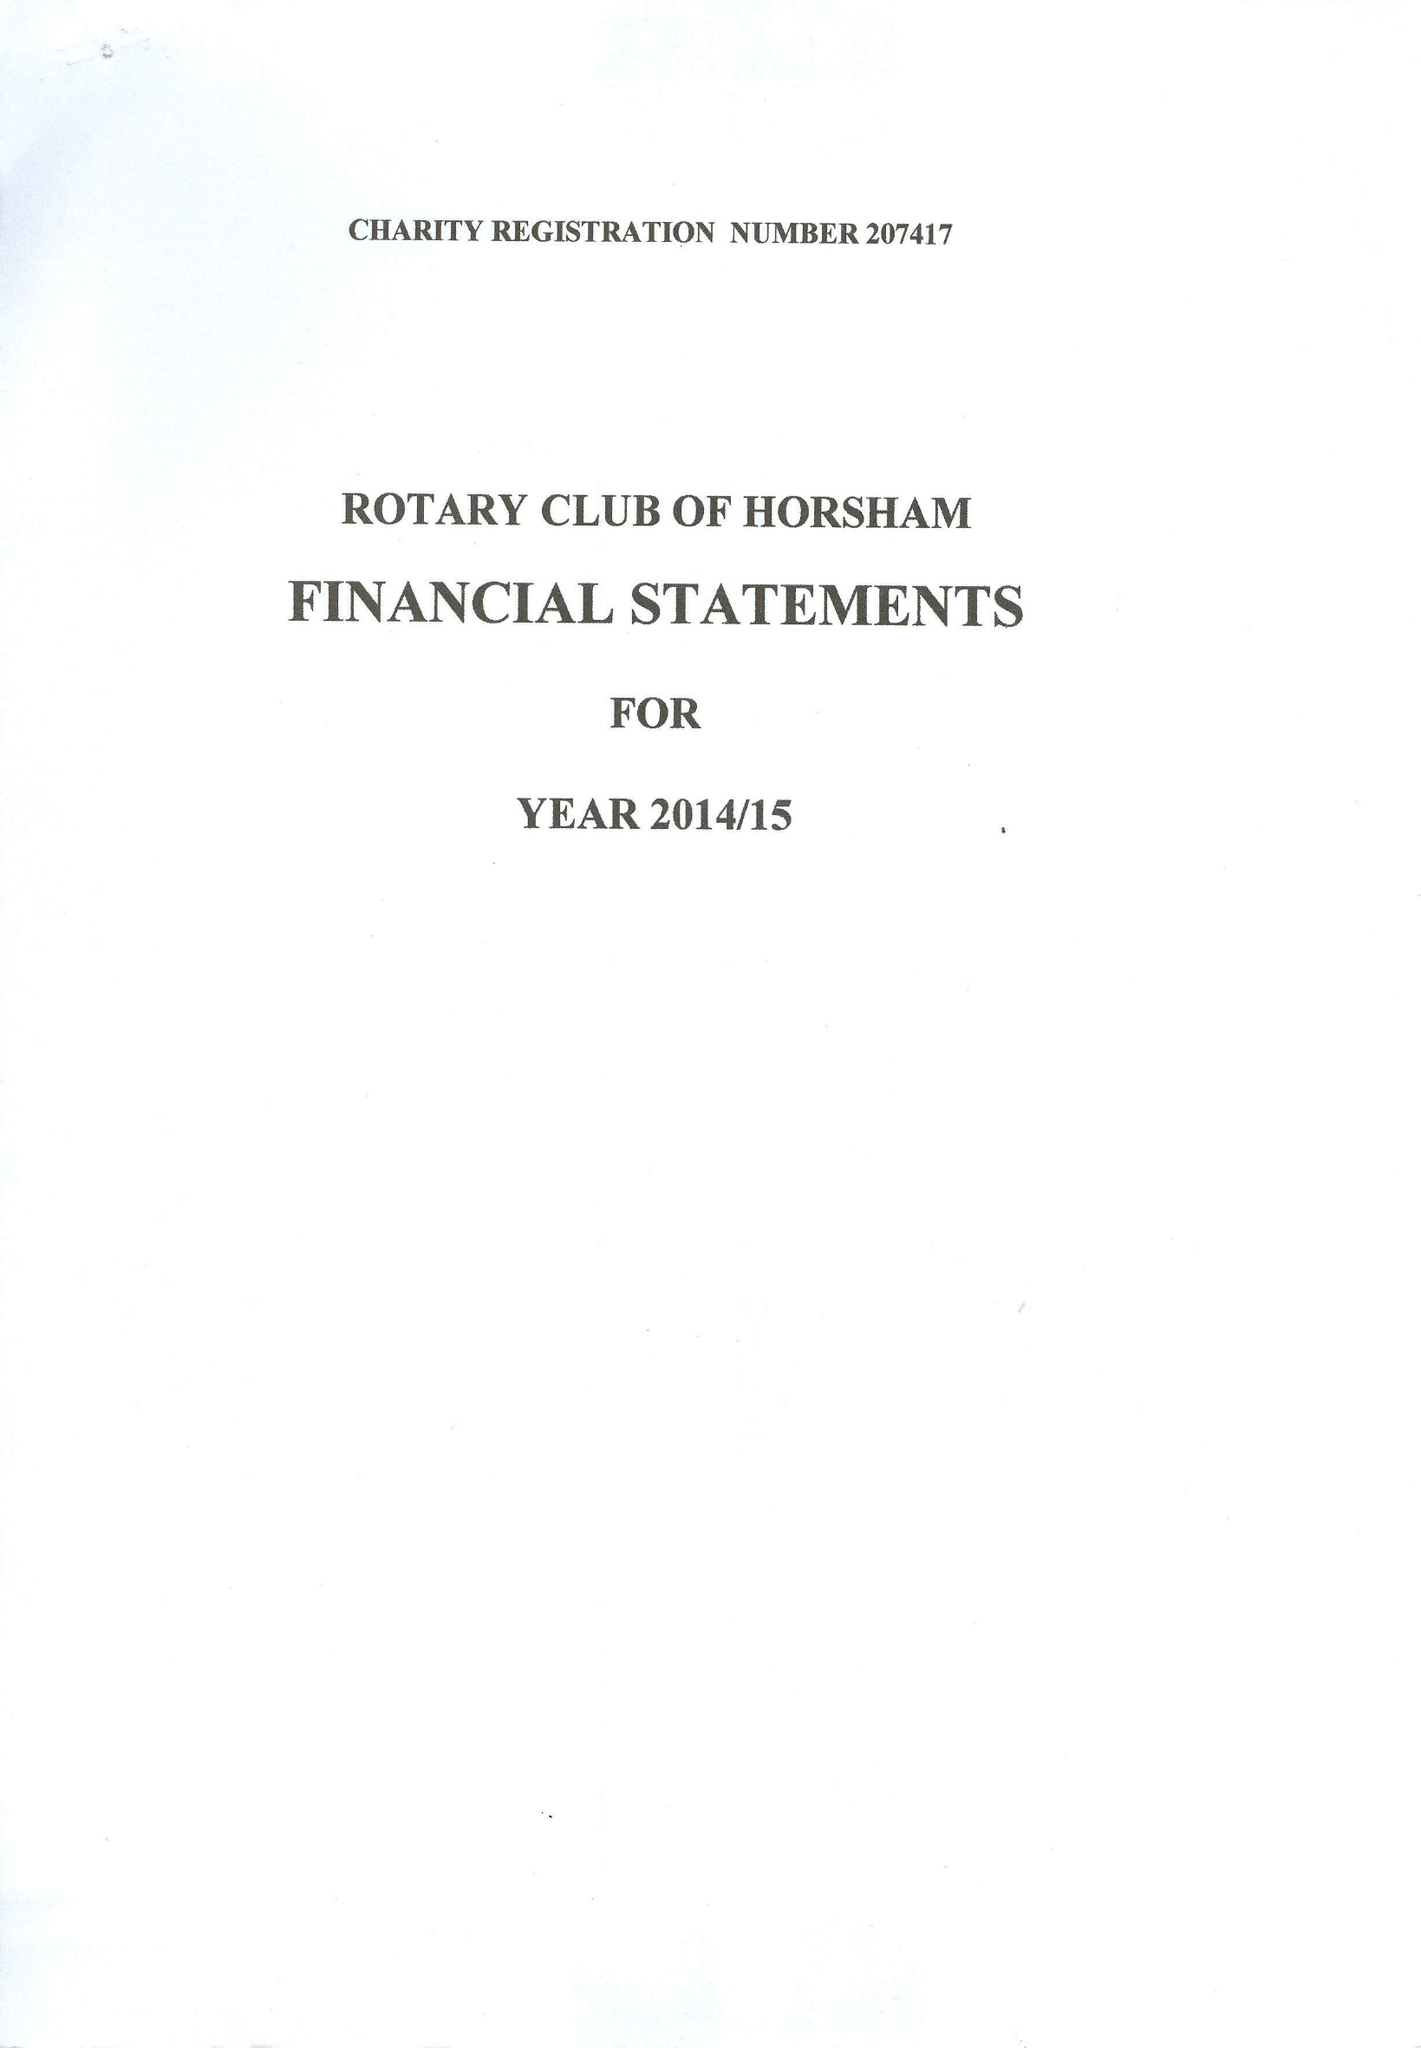What is the value for the address__postcode?
Answer the question using a single word or phrase. RH5 5AR 